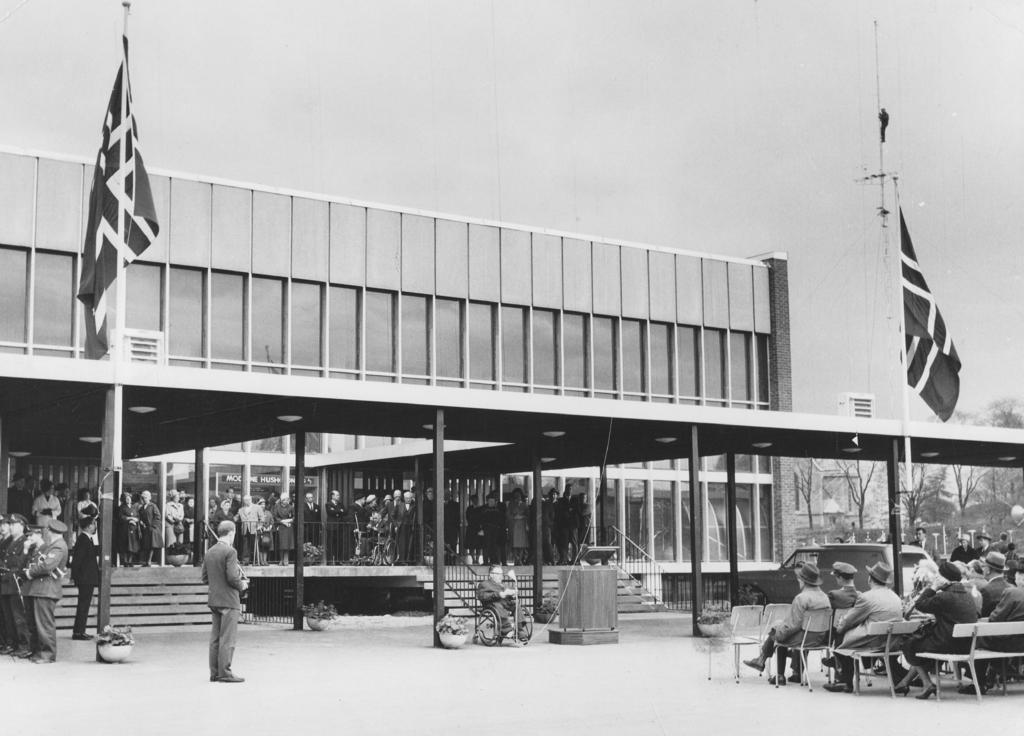Describe this image in one or two sentences. In this image there is an old black and white photograph, in the photograph there are a few people seated in chairs in front of a building, there are two flags hoisted in front of the building, inside the building there are few other people standing, in front of them there are stairs, in front of the stairs there is a person seated in a wheelchair, beside the person there is dais, beside the building the building there are few other buildings and trees. 